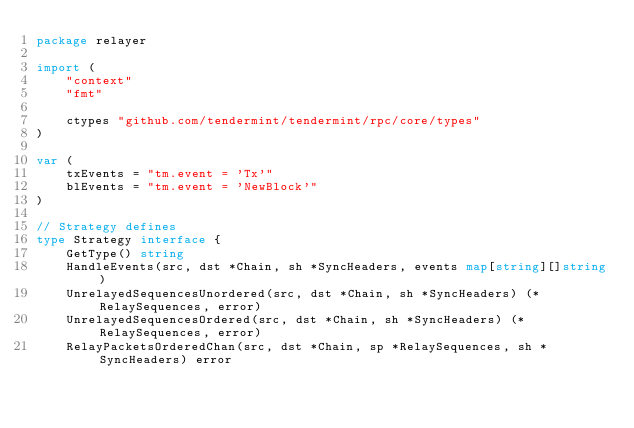<code> <loc_0><loc_0><loc_500><loc_500><_Go_>package relayer

import (
	"context"
	"fmt"

	ctypes "github.com/tendermint/tendermint/rpc/core/types"
)

var (
	txEvents = "tm.event = 'Tx'"
	blEvents = "tm.event = 'NewBlock'"
)

// Strategy defines
type Strategy interface {
	GetType() string
	HandleEvents(src, dst *Chain, sh *SyncHeaders, events map[string][]string)
	UnrelayedSequencesUnordered(src, dst *Chain, sh *SyncHeaders) (*RelaySequences, error)
	UnrelayedSequencesOrdered(src, dst *Chain, sh *SyncHeaders) (*RelaySequences, error)
	RelayPacketsOrderedChan(src, dst *Chain, sp *RelaySequences, sh *SyncHeaders) error</code> 